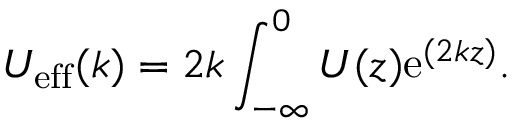<formula> <loc_0><loc_0><loc_500><loc_500>U _ { e f f } ( k ) = 2 k \int _ { - \infty } ^ { 0 } U ( z ) e ^ { ( 2 k z ) } .</formula> 